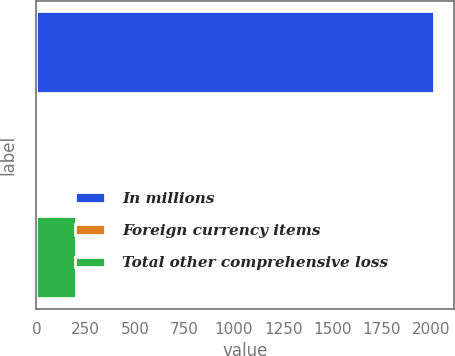Convert chart. <chart><loc_0><loc_0><loc_500><loc_500><bar_chart><fcel>In millions<fcel>Foreign currency items<fcel>Total other comprehensive loss<nl><fcel>2017<fcel>0.6<fcel>202.24<nl></chart> 